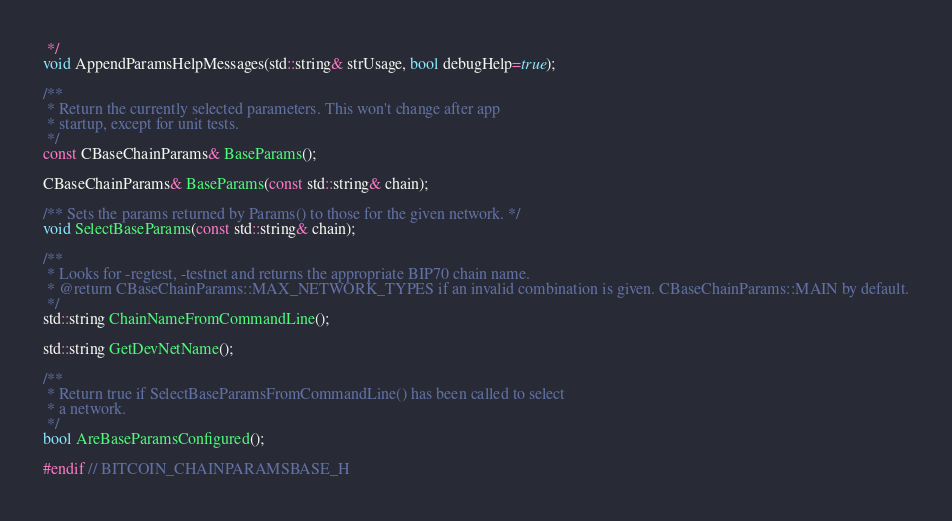<code> <loc_0><loc_0><loc_500><loc_500><_C_> */
void AppendParamsHelpMessages(std::string& strUsage, bool debugHelp=true);

/**
 * Return the currently selected parameters. This won't change after app
 * startup, except for unit tests.
 */
const CBaseChainParams& BaseParams();

CBaseChainParams& BaseParams(const std::string& chain);

/** Sets the params returned by Params() to those for the given network. */
void SelectBaseParams(const std::string& chain);

/**
 * Looks for -regtest, -testnet and returns the appropriate BIP70 chain name.
 * @return CBaseChainParams::MAX_NETWORK_TYPES if an invalid combination is given. CBaseChainParams::MAIN by default.
 */
std::string ChainNameFromCommandLine();

std::string GetDevNetName();

/**
 * Return true if SelectBaseParamsFromCommandLine() has been called to select
 * a network.
 */
bool AreBaseParamsConfigured();

#endif // BITCOIN_CHAINPARAMSBASE_H
</code> 